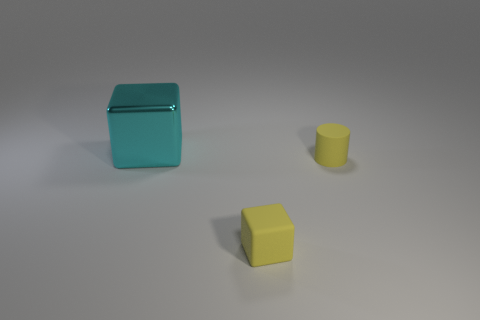Is the material of the cube that is behind the tiny cube the same as the thing that is in front of the small yellow matte cylinder?
Make the answer very short. No. What is the big cyan cube made of?
Ensure brevity in your answer.  Metal. Are there more tiny cylinders right of the big metallic thing than large metallic things?
Keep it short and to the point. No. How many small yellow things are right of the rubber thing in front of the thing to the right of the rubber block?
Provide a short and direct response. 1. There is a thing that is in front of the cyan block and behind the tiny rubber cube; what is its material?
Offer a terse response. Rubber. What color is the big shiny block?
Your answer should be compact. Cyan. Is the number of small objects behind the tiny yellow matte block greater than the number of yellow objects left of the cyan object?
Provide a succinct answer. Yes. What is the color of the block that is on the right side of the cyan shiny cube?
Offer a very short reply. Yellow. Do the rubber object on the left side of the tiny yellow matte cylinder and the block that is behind the matte cylinder have the same size?
Give a very brief answer. No. What number of things are either small yellow blocks or small yellow matte cylinders?
Provide a succinct answer. 2. 